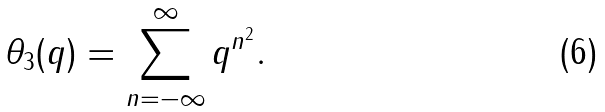<formula> <loc_0><loc_0><loc_500><loc_500>\theta _ { 3 } ( q ) = \sum _ { n = - \infty } ^ { \infty } q ^ { n ^ { 2 } } .</formula> 